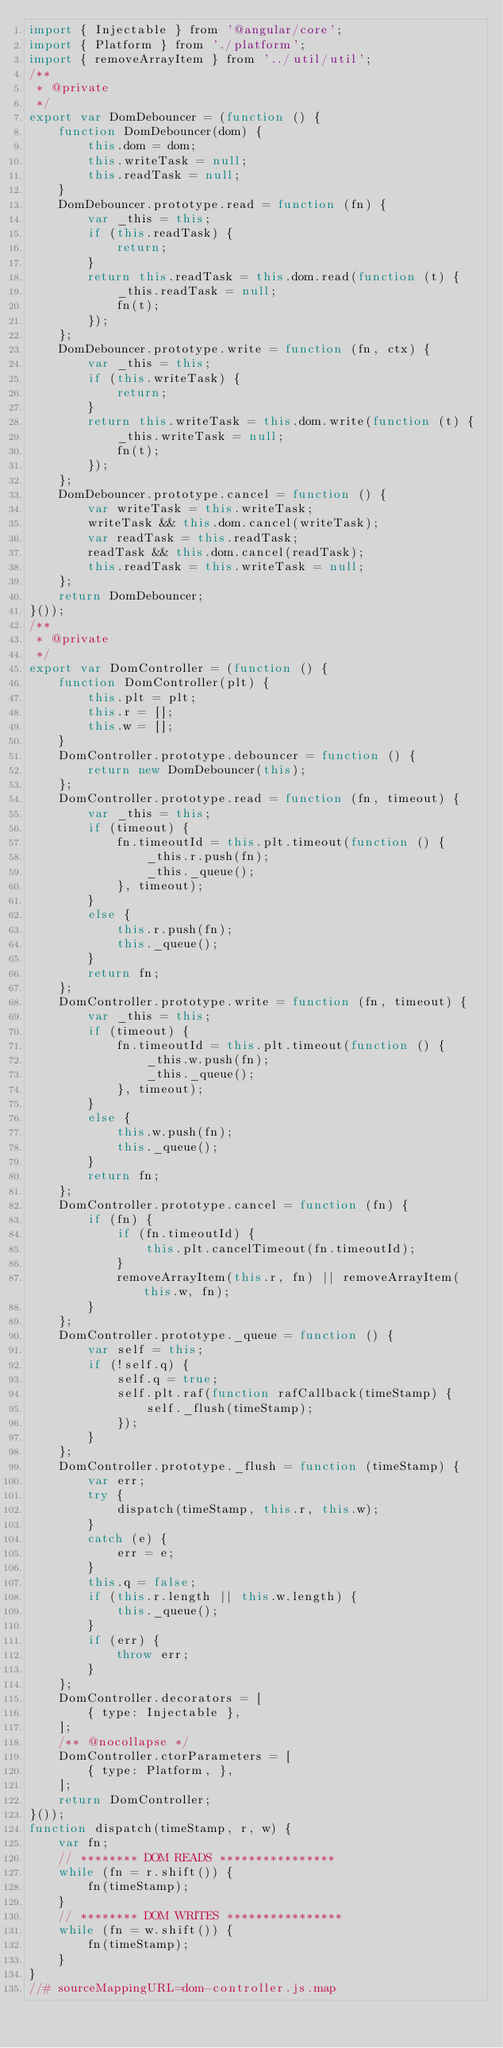<code> <loc_0><loc_0><loc_500><loc_500><_JavaScript_>import { Injectable } from '@angular/core';
import { Platform } from './platform';
import { removeArrayItem } from '../util/util';
/**
 * @private
 */
export var DomDebouncer = (function () {
    function DomDebouncer(dom) {
        this.dom = dom;
        this.writeTask = null;
        this.readTask = null;
    }
    DomDebouncer.prototype.read = function (fn) {
        var _this = this;
        if (this.readTask) {
            return;
        }
        return this.readTask = this.dom.read(function (t) {
            _this.readTask = null;
            fn(t);
        });
    };
    DomDebouncer.prototype.write = function (fn, ctx) {
        var _this = this;
        if (this.writeTask) {
            return;
        }
        return this.writeTask = this.dom.write(function (t) {
            _this.writeTask = null;
            fn(t);
        });
    };
    DomDebouncer.prototype.cancel = function () {
        var writeTask = this.writeTask;
        writeTask && this.dom.cancel(writeTask);
        var readTask = this.readTask;
        readTask && this.dom.cancel(readTask);
        this.readTask = this.writeTask = null;
    };
    return DomDebouncer;
}());
/**
 * @private
 */
export var DomController = (function () {
    function DomController(plt) {
        this.plt = plt;
        this.r = [];
        this.w = [];
    }
    DomController.prototype.debouncer = function () {
        return new DomDebouncer(this);
    };
    DomController.prototype.read = function (fn, timeout) {
        var _this = this;
        if (timeout) {
            fn.timeoutId = this.plt.timeout(function () {
                _this.r.push(fn);
                _this._queue();
            }, timeout);
        }
        else {
            this.r.push(fn);
            this._queue();
        }
        return fn;
    };
    DomController.prototype.write = function (fn, timeout) {
        var _this = this;
        if (timeout) {
            fn.timeoutId = this.plt.timeout(function () {
                _this.w.push(fn);
                _this._queue();
            }, timeout);
        }
        else {
            this.w.push(fn);
            this._queue();
        }
        return fn;
    };
    DomController.prototype.cancel = function (fn) {
        if (fn) {
            if (fn.timeoutId) {
                this.plt.cancelTimeout(fn.timeoutId);
            }
            removeArrayItem(this.r, fn) || removeArrayItem(this.w, fn);
        }
    };
    DomController.prototype._queue = function () {
        var self = this;
        if (!self.q) {
            self.q = true;
            self.plt.raf(function rafCallback(timeStamp) {
                self._flush(timeStamp);
            });
        }
    };
    DomController.prototype._flush = function (timeStamp) {
        var err;
        try {
            dispatch(timeStamp, this.r, this.w);
        }
        catch (e) {
            err = e;
        }
        this.q = false;
        if (this.r.length || this.w.length) {
            this._queue();
        }
        if (err) {
            throw err;
        }
    };
    DomController.decorators = [
        { type: Injectable },
    ];
    /** @nocollapse */
    DomController.ctorParameters = [
        { type: Platform, },
    ];
    return DomController;
}());
function dispatch(timeStamp, r, w) {
    var fn;
    // ******** DOM READS ****************
    while (fn = r.shift()) {
        fn(timeStamp);
    }
    // ******** DOM WRITES ****************
    while (fn = w.shift()) {
        fn(timeStamp);
    }
}
//# sourceMappingURL=dom-controller.js.map</code> 